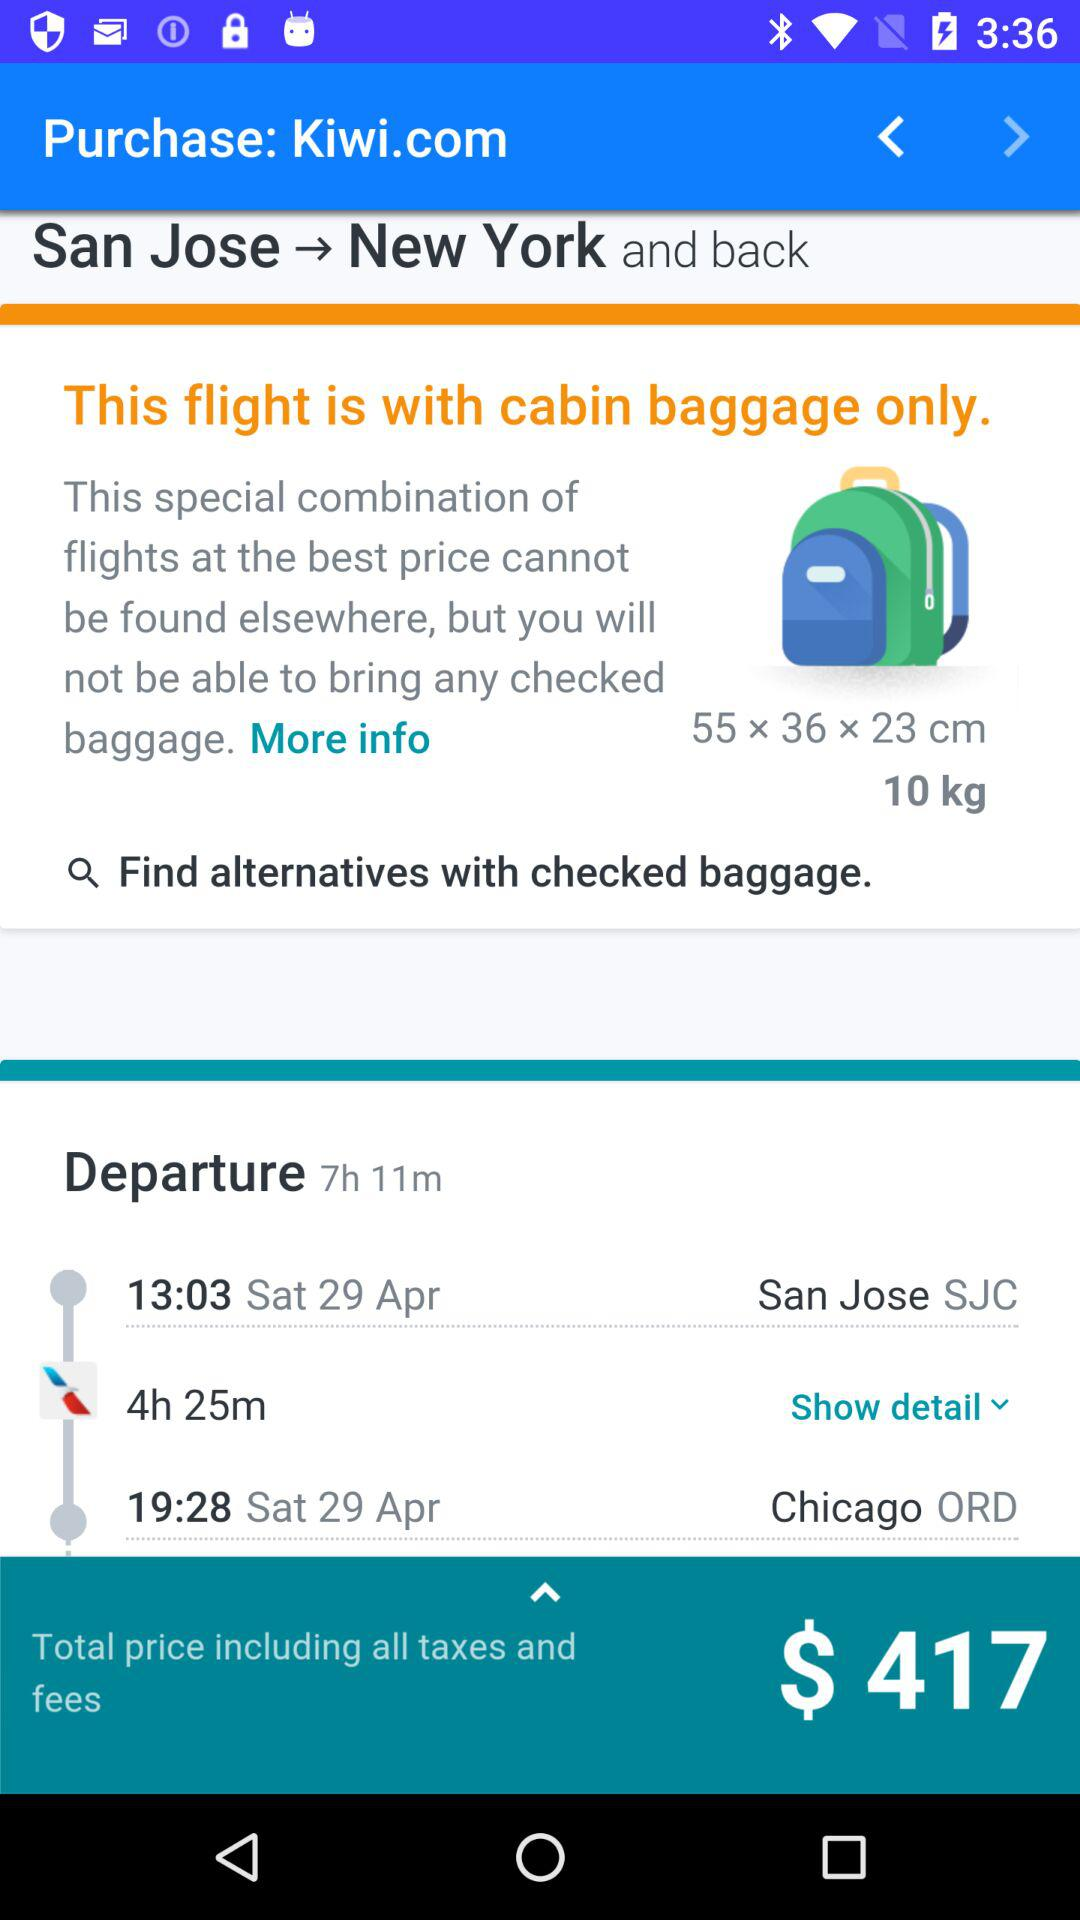The journey is from which city to which city? The journey is from San Jose to Chigaco. 